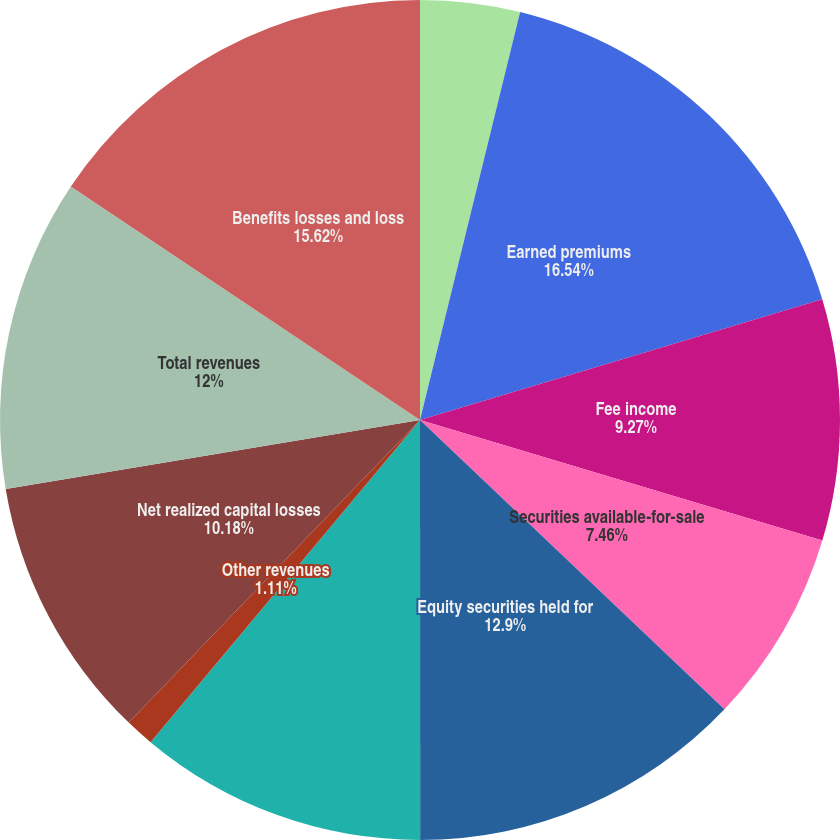Convert chart to OTSL. <chart><loc_0><loc_0><loc_500><loc_500><pie_chart><fcel>Operating Summary<fcel>Earned premiums<fcel>Fee income<fcel>Securities available-for-sale<fcel>Equity securities held for<fcel>Total net investment income<fcel>Other revenues<fcel>Net realized capital losses<fcel>Total revenues<fcel>Benefits losses and loss<nl><fcel>3.83%<fcel>16.53%<fcel>9.27%<fcel>7.46%<fcel>12.9%<fcel>11.09%<fcel>1.11%<fcel>10.18%<fcel>12.0%<fcel>15.62%<nl></chart> 